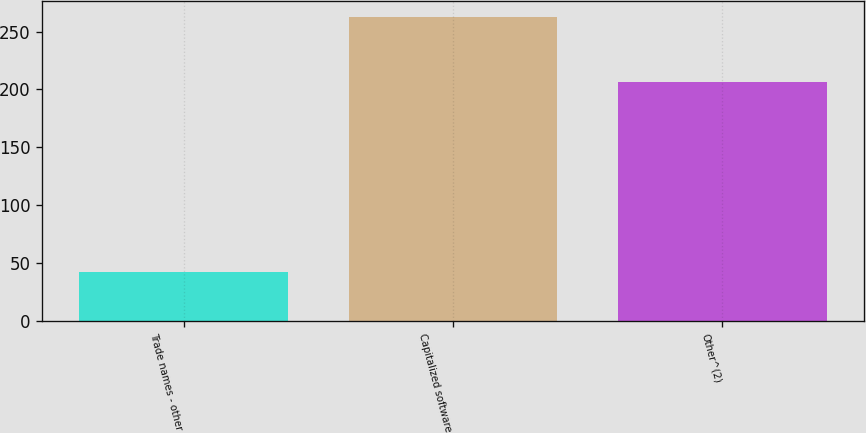Convert chart to OTSL. <chart><loc_0><loc_0><loc_500><loc_500><bar_chart><fcel>Trade names - other<fcel>Capitalized software<fcel>Other^(2)<nl><fcel>41.6<fcel>262.9<fcel>206.7<nl></chart> 